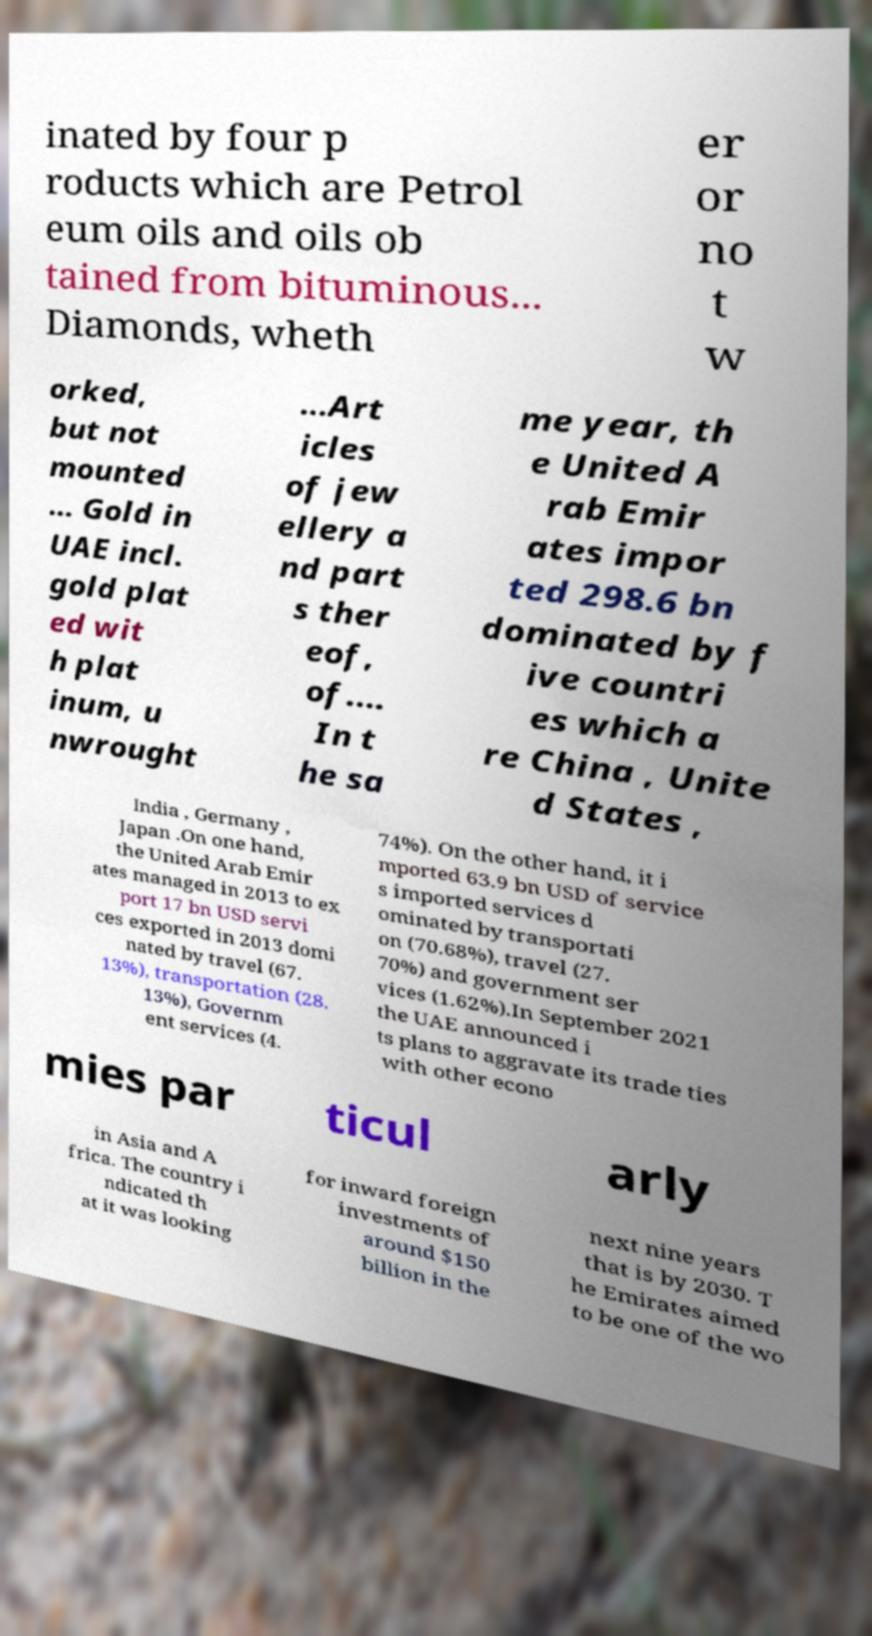Please identify and transcribe the text found in this image. inated by four p roducts which are Petrol eum oils and oils ob tained from bituminous... Diamonds, wheth er or no t w orked, but not mounted ... Gold in UAE incl. gold plat ed wit h plat inum, u nwrought ...Art icles of jew ellery a nd part s ther eof, of.... In t he sa me year, th e United A rab Emir ates impor ted 298.6 bn dominated by f ive countri es which a re China , Unite d States , India , Germany , Japan .On one hand, the United Arab Emir ates managed in 2013 to ex port 17 bn USD servi ces exported in 2013 domi nated by travel (67. 13%), transportation (28. 13%), Governm ent services (4. 74%). On the other hand, it i mported 63.9 bn USD of service s imported services d ominated by transportati on (70.68%), travel (27. 70%) and government ser vices (1.62%).In September 2021 the UAE announced i ts plans to aggravate its trade ties with other econo mies par ticul arly in Asia and A frica. The country i ndicated th at it was looking for inward foreign investments of around $150 billion in the next nine years that is by 2030. T he Emirates aimed to be one of the wo 